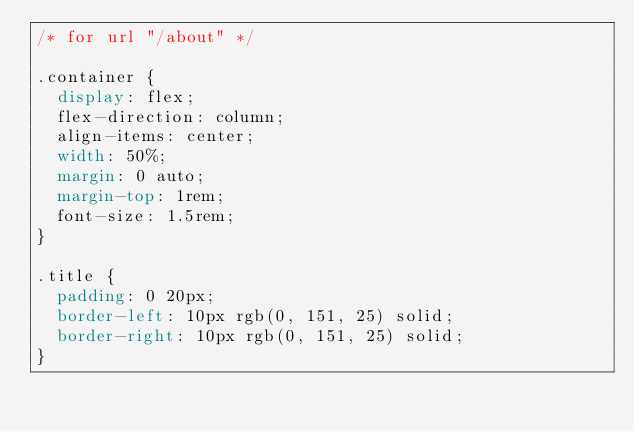<code> <loc_0><loc_0><loc_500><loc_500><_CSS_>/* for url "/about" */

.container {
  display: flex;
  flex-direction: column;
  align-items: center;
  width: 50%;
  margin: 0 auto;
  margin-top: 1rem;
  font-size: 1.5rem;
}

.title {
  padding: 0 20px;
  border-left: 10px rgb(0, 151, 25) solid;
  border-right: 10px rgb(0, 151, 25) solid;
}
</code> 